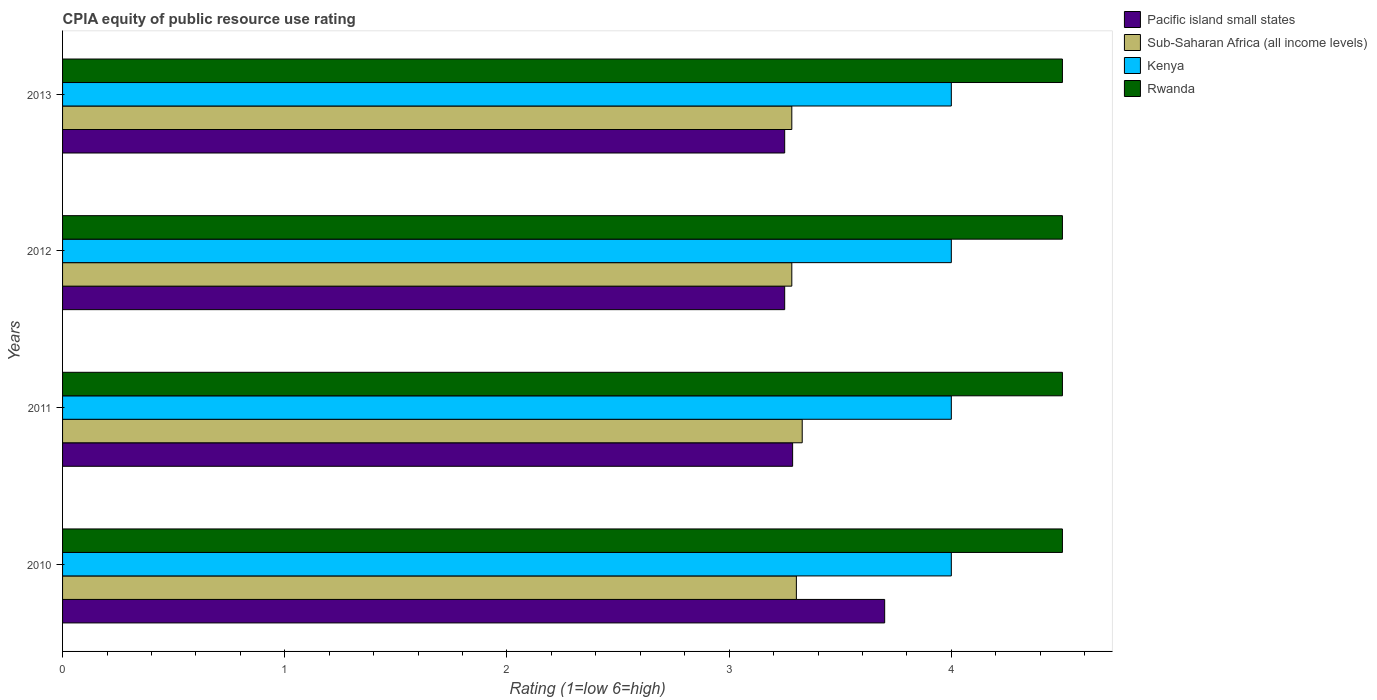How many different coloured bars are there?
Keep it short and to the point. 4. How many groups of bars are there?
Give a very brief answer. 4. Are the number of bars per tick equal to the number of legend labels?
Ensure brevity in your answer.  Yes. Are the number of bars on each tick of the Y-axis equal?
Your answer should be compact. Yes. What is the CPIA rating in Kenya in 2010?
Provide a short and direct response. 4. Across all years, what is the maximum CPIA rating in Kenya?
Provide a short and direct response. 4. Across all years, what is the minimum CPIA rating in Rwanda?
Ensure brevity in your answer.  4.5. In which year was the CPIA rating in Rwanda minimum?
Make the answer very short. 2010. What is the total CPIA rating in Kenya in the graph?
Give a very brief answer. 16. What is the difference between the CPIA rating in Sub-Saharan Africa (all income levels) in 2011 and that in 2012?
Your response must be concise. 0.05. What is the difference between the CPIA rating in Pacific island small states in 2011 and the CPIA rating in Kenya in 2013?
Your answer should be compact. -0.71. What is the average CPIA rating in Kenya per year?
Provide a short and direct response. 4. In the year 2010, what is the difference between the CPIA rating in Sub-Saharan Africa (all income levels) and CPIA rating in Rwanda?
Offer a terse response. -1.2. What is the ratio of the CPIA rating in Pacific island small states in 2011 to that in 2012?
Your answer should be compact. 1.01. What is the difference between the highest and the second highest CPIA rating in Pacific island small states?
Ensure brevity in your answer.  0.41. What is the difference between the highest and the lowest CPIA rating in Rwanda?
Your answer should be very brief. 0. In how many years, is the CPIA rating in Pacific island small states greater than the average CPIA rating in Pacific island small states taken over all years?
Your answer should be very brief. 1. Is the sum of the CPIA rating in Rwanda in 2012 and 2013 greater than the maximum CPIA rating in Pacific island small states across all years?
Keep it short and to the point. Yes. Is it the case that in every year, the sum of the CPIA rating in Kenya and CPIA rating in Sub-Saharan Africa (all income levels) is greater than the sum of CPIA rating in Rwanda and CPIA rating in Pacific island small states?
Offer a terse response. No. What does the 4th bar from the top in 2013 represents?
Your answer should be compact. Pacific island small states. What does the 2nd bar from the bottom in 2010 represents?
Offer a terse response. Sub-Saharan Africa (all income levels). Is it the case that in every year, the sum of the CPIA rating in Kenya and CPIA rating in Rwanda is greater than the CPIA rating in Pacific island small states?
Make the answer very short. Yes. Are all the bars in the graph horizontal?
Give a very brief answer. Yes. What is the difference between two consecutive major ticks on the X-axis?
Provide a short and direct response. 1. Does the graph contain grids?
Make the answer very short. No. What is the title of the graph?
Provide a short and direct response. CPIA equity of public resource use rating. Does "Pacific island small states" appear as one of the legend labels in the graph?
Offer a very short reply. Yes. What is the label or title of the Y-axis?
Give a very brief answer. Years. What is the Rating (1=low 6=high) of Sub-Saharan Africa (all income levels) in 2010?
Your answer should be very brief. 3.3. What is the Rating (1=low 6=high) of Pacific island small states in 2011?
Give a very brief answer. 3.29. What is the Rating (1=low 6=high) of Sub-Saharan Africa (all income levels) in 2011?
Give a very brief answer. 3.33. What is the Rating (1=low 6=high) in Sub-Saharan Africa (all income levels) in 2012?
Make the answer very short. 3.28. What is the Rating (1=low 6=high) of Rwanda in 2012?
Keep it short and to the point. 4.5. What is the Rating (1=low 6=high) of Pacific island small states in 2013?
Provide a succinct answer. 3.25. What is the Rating (1=low 6=high) in Sub-Saharan Africa (all income levels) in 2013?
Your answer should be very brief. 3.28. What is the Rating (1=low 6=high) in Kenya in 2013?
Offer a terse response. 4. Across all years, what is the maximum Rating (1=low 6=high) of Pacific island small states?
Provide a succinct answer. 3.7. Across all years, what is the maximum Rating (1=low 6=high) in Sub-Saharan Africa (all income levels)?
Make the answer very short. 3.33. Across all years, what is the minimum Rating (1=low 6=high) of Sub-Saharan Africa (all income levels)?
Ensure brevity in your answer.  3.28. Across all years, what is the minimum Rating (1=low 6=high) in Kenya?
Your answer should be compact. 4. Across all years, what is the minimum Rating (1=low 6=high) of Rwanda?
Give a very brief answer. 4.5. What is the total Rating (1=low 6=high) of Pacific island small states in the graph?
Make the answer very short. 13.49. What is the total Rating (1=low 6=high) in Sub-Saharan Africa (all income levels) in the graph?
Your answer should be very brief. 13.2. What is the total Rating (1=low 6=high) of Kenya in the graph?
Your answer should be very brief. 16. What is the difference between the Rating (1=low 6=high) in Pacific island small states in 2010 and that in 2011?
Offer a terse response. 0.41. What is the difference between the Rating (1=low 6=high) in Sub-Saharan Africa (all income levels) in 2010 and that in 2011?
Provide a succinct answer. -0.03. What is the difference between the Rating (1=low 6=high) in Kenya in 2010 and that in 2011?
Your answer should be compact. 0. What is the difference between the Rating (1=low 6=high) of Pacific island small states in 2010 and that in 2012?
Keep it short and to the point. 0.45. What is the difference between the Rating (1=low 6=high) of Sub-Saharan Africa (all income levels) in 2010 and that in 2012?
Provide a succinct answer. 0.02. What is the difference between the Rating (1=low 6=high) in Rwanda in 2010 and that in 2012?
Your answer should be compact. 0. What is the difference between the Rating (1=low 6=high) in Pacific island small states in 2010 and that in 2013?
Give a very brief answer. 0.45. What is the difference between the Rating (1=low 6=high) of Sub-Saharan Africa (all income levels) in 2010 and that in 2013?
Make the answer very short. 0.02. What is the difference between the Rating (1=low 6=high) of Kenya in 2010 and that in 2013?
Offer a very short reply. 0. What is the difference between the Rating (1=low 6=high) of Pacific island small states in 2011 and that in 2012?
Keep it short and to the point. 0.04. What is the difference between the Rating (1=low 6=high) in Sub-Saharan Africa (all income levels) in 2011 and that in 2012?
Offer a very short reply. 0.05. What is the difference between the Rating (1=low 6=high) in Rwanda in 2011 and that in 2012?
Ensure brevity in your answer.  0. What is the difference between the Rating (1=low 6=high) of Pacific island small states in 2011 and that in 2013?
Provide a short and direct response. 0.04. What is the difference between the Rating (1=low 6=high) of Sub-Saharan Africa (all income levels) in 2011 and that in 2013?
Keep it short and to the point. 0.05. What is the difference between the Rating (1=low 6=high) in Kenya in 2011 and that in 2013?
Keep it short and to the point. 0. What is the difference between the Rating (1=low 6=high) of Rwanda in 2011 and that in 2013?
Your response must be concise. 0. What is the difference between the Rating (1=low 6=high) in Pacific island small states in 2010 and the Rating (1=low 6=high) in Sub-Saharan Africa (all income levels) in 2011?
Provide a succinct answer. 0.37. What is the difference between the Rating (1=low 6=high) of Sub-Saharan Africa (all income levels) in 2010 and the Rating (1=low 6=high) of Kenya in 2011?
Your answer should be very brief. -0.7. What is the difference between the Rating (1=low 6=high) in Sub-Saharan Africa (all income levels) in 2010 and the Rating (1=low 6=high) in Rwanda in 2011?
Keep it short and to the point. -1.2. What is the difference between the Rating (1=low 6=high) in Kenya in 2010 and the Rating (1=low 6=high) in Rwanda in 2011?
Your answer should be compact. -0.5. What is the difference between the Rating (1=low 6=high) in Pacific island small states in 2010 and the Rating (1=low 6=high) in Sub-Saharan Africa (all income levels) in 2012?
Provide a succinct answer. 0.42. What is the difference between the Rating (1=low 6=high) of Pacific island small states in 2010 and the Rating (1=low 6=high) of Kenya in 2012?
Your answer should be compact. -0.3. What is the difference between the Rating (1=low 6=high) in Sub-Saharan Africa (all income levels) in 2010 and the Rating (1=low 6=high) in Kenya in 2012?
Keep it short and to the point. -0.7. What is the difference between the Rating (1=low 6=high) of Sub-Saharan Africa (all income levels) in 2010 and the Rating (1=low 6=high) of Rwanda in 2012?
Keep it short and to the point. -1.2. What is the difference between the Rating (1=low 6=high) of Pacific island small states in 2010 and the Rating (1=low 6=high) of Sub-Saharan Africa (all income levels) in 2013?
Offer a terse response. 0.42. What is the difference between the Rating (1=low 6=high) of Pacific island small states in 2010 and the Rating (1=low 6=high) of Kenya in 2013?
Your answer should be very brief. -0.3. What is the difference between the Rating (1=low 6=high) of Sub-Saharan Africa (all income levels) in 2010 and the Rating (1=low 6=high) of Kenya in 2013?
Keep it short and to the point. -0.7. What is the difference between the Rating (1=low 6=high) in Sub-Saharan Africa (all income levels) in 2010 and the Rating (1=low 6=high) in Rwanda in 2013?
Provide a succinct answer. -1.2. What is the difference between the Rating (1=low 6=high) in Pacific island small states in 2011 and the Rating (1=low 6=high) in Sub-Saharan Africa (all income levels) in 2012?
Your answer should be very brief. 0. What is the difference between the Rating (1=low 6=high) in Pacific island small states in 2011 and the Rating (1=low 6=high) in Kenya in 2012?
Your response must be concise. -0.71. What is the difference between the Rating (1=low 6=high) in Pacific island small states in 2011 and the Rating (1=low 6=high) in Rwanda in 2012?
Provide a succinct answer. -1.21. What is the difference between the Rating (1=low 6=high) of Sub-Saharan Africa (all income levels) in 2011 and the Rating (1=low 6=high) of Kenya in 2012?
Offer a very short reply. -0.67. What is the difference between the Rating (1=low 6=high) in Sub-Saharan Africa (all income levels) in 2011 and the Rating (1=low 6=high) in Rwanda in 2012?
Your answer should be very brief. -1.17. What is the difference between the Rating (1=low 6=high) in Pacific island small states in 2011 and the Rating (1=low 6=high) in Sub-Saharan Africa (all income levels) in 2013?
Ensure brevity in your answer.  0. What is the difference between the Rating (1=low 6=high) of Pacific island small states in 2011 and the Rating (1=low 6=high) of Kenya in 2013?
Your answer should be very brief. -0.71. What is the difference between the Rating (1=low 6=high) in Pacific island small states in 2011 and the Rating (1=low 6=high) in Rwanda in 2013?
Provide a succinct answer. -1.21. What is the difference between the Rating (1=low 6=high) of Sub-Saharan Africa (all income levels) in 2011 and the Rating (1=low 6=high) of Kenya in 2013?
Keep it short and to the point. -0.67. What is the difference between the Rating (1=low 6=high) in Sub-Saharan Africa (all income levels) in 2011 and the Rating (1=low 6=high) in Rwanda in 2013?
Ensure brevity in your answer.  -1.17. What is the difference between the Rating (1=low 6=high) in Pacific island small states in 2012 and the Rating (1=low 6=high) in Sub-Saharan Africa (all income levels) in 2013?
Provide a short and direct response. -0.03. What is the difference between the Rating (1=low 6=high) of Pacific island small states in 2012 and the Rating (1=low 6=high) of Kenya in 2013?
Provide a short and direct response. -0.75. What is the difference between the Rating (1=low 6=high) in Pacific island small states in 2012 and the Rating (1=low 6=high) in Rwanda in 2013?
Provide a succinct answer. -1.25. What is the difference between the Rating (1=low 6=high) of Sub-Saharan Africa (all income levels) in 2012 and the Rating (1=low 6=high) of Kenya in 2013?
Provide a succinct answer. -0.72. What is the difference between the Rating (1=low 6=high) of Sub-Saharan Africa (all income levels) in 2012 and the Rating (1=low 6=high) of Rwanda in 2013?
Keep it short and to the point. -1.22. What is the average Rating (1=low 6=high) of Pacific island small states per year?
Offer a terse response. 3.37. What is the average Rating (1=low 6=high) of Sub-Saharan Africa (all income levels) per year?
Ensure brevity in your answer.  3.3. In the year 2010, what is the difference between the Rating (1=low 6=high) of Pacific island small states and Rating (1=low 6=high) of Sub-Saharan Africa (all income levels)?
Your answer should be compact. 0.4. In the year 2010, what is the difference between the Rating (1=low 6=high) in Pacific island small states and Rating (1=low 6=high) in Rwanda?
Offer a very short reply. -0.8. In the year 2010, what is the difference between the Rating (1=low 6=high) in Sub-Saharan Africa (all income levels) and Rating (1=low 6=high) in Kenya?
Ensure brevity in your answer.  -0.7. In the year 2010, what is the difference between the Rating (1=low 6=high) of Sub-Saharan Africa (all income levels) and Rating (1=low 6=high) of Rwanda?
Provide a short and direct response. -1.2. In the year 2011, what is the difference between the Rating (1=low 6=high) in Pacific island small states and Rating (1=low 6=high) in Sub-Saharan Africa (all income levels)?
Ensure brevity in your answer.  -0.04. In the year 2011, what is the difference between the Rating (1=low 6=high) in Pacific island small states and Rating (1=low 6=high) in Kenya?
Provide a succinct answer. -0.71. In the year 2011, what is the difference between the Rating (1=low 6=high) of Pacific island small states and Rating (1=low 6=high) of Rwanda?
Provide a short and direct response. -1.21. In the year 2011, what is the difference between the Rating (1=low 6=high) of Sub-Saharan Africa (all income levels) and Rating (1=low 6=high) of Kenya?
Provide a short and direct response. -0.67. In the year 2011, what is the difference between the Rating (1=low 6=high) in Sub-Saharan Africa (all income levels) and Rating (1=low 6=high) in Rwanda?
Your answer should be very brief. -1.17. In the year 2012, what is the difference between the Rating (1=low 6=high) of Pacific island small states and Rating (1=low 6=high) of Sub-Saharan Africa (all income levels)?
Provide a succinct answer. -0.03. In the year 2012, what is the difference between the Rating (1=low 6=high) in Pacific island small states and Rating (1=low 6=high) in Kenya?
Make the answer very short. -0.75. In the year 2012, what is the difference between the Rating (1=low 6=high) of Pacific island small states and Rating (1=low 6=high) of Rwanda?
Your answer should be compact. -1.25. In the year 2012, what is the difference between the Rating (1=low 6=high) of Sub-Saharan Africa (all income levels) and Rating (1=low 6=high) of Kenya?
Offer a very short reply. -0.72. In the year 2012, what is the difference between the Rating (1=low 6=high) in Sub-Saharan Africa (all income levels) and Rating (1=low 6=high) in Rwanda?
Your response must be concise. -1.22. In the year 2013, what is the difference between the Rating (1=low 6=high) in Pacific island small states and Rating (1=low 6=high) in Sub-Saharan Africa (all income levels)?
Offer a very short reply. -0.03. In the year 2013, what is the difference between the Rating (1=low 6=high) in Pacific island small states and Rating (1=low 6=high) in Kenya?
Keep it short and to the point. -0.75. In the year 2013, what is the difference between the Rating (1=low 6=high) in Pacific island small states and Rating (1=low 6=high) in Rwanda?
Give a very brief answer. -1.25. In the year 2013, what is the difference between the Rating (1=low 6=high) in Sub-Saharan Africa (all income levels) and Rating (1=low 6=high) in Kenya?
Your answer should be compact. -0.72. In the year 2013, what is the difference between the Rating (1=low 6=high) of Sub-Saharan Africa (all income levels) and Rating (1=low 6=high) of Rwanda?
Make the answer very short. -1.22. In the year 2013, what is the difference between the Rating (1=low 6=high) of Kenya and Rating (1=low 6=high) of Rwanda?
Offer a very short reply. -0.5. What is the ratio of the Rating (1=low 6=high) of Pacific island small states in 2010 to that in 2011?
Your response must be concise. 1.13. What is the ratio of the Rating (1=low 6=high) in Kenya in 2010 to that in 2011?
Offer a very short reply. 1. What is the ratio of the Rating (1=low 6=high) of Pacific island small states in 2010 to that in 2012?
Offer a terse response. 1.14. What is the ratio of the Rating (1=low 6=high) of Kenya in 2010 to that in 2012?
Offer a very short reply. 1. What is the ratio of the Rating (1=low 6=high) of Rwanda in 2010 to that in 2012?
Your answer should be very brief. 1. What is the ratio of the Rating (1=low 6=high) of Pacific island small states in 2010 to that in 2013?
Give a very brief answer. 1.14. What is the ratio of the Rating (1=low 6=high) in Rwanda in 2010 to that in 2013?
Offer a very short reply. 1. What is the ratio of the Rating (1=low 6=high) of Pacific island small states in 2011 to that in 2012?
Keep it short and to the point. 1.01. What is the ratio of the Rating (1=low 6=high) of Sub-Saharan Africa (all income levels) in 2011 to that in 2012?
Ensure brevity in your answer.  1.01. What is the ratio of the Rating (1=low 6=high) of Pacific island small states in 2011 to that in 2013?
Offer a terse response. 1.01. What is the ratio of the Rating (1=low 6=high) in Sub-Saharan Africa (all income levels) in 2011 to that in 2013?
Your answer should be very brief. 1.01. What is the ratio of the Rating (1=low 6=high) in Kenya in 2011 to that in 2013?
Your answer should be compact. 1. What is the ratio of the Rating (1=low 6=high) of Rwanda in 2011 to that in 2013?
Give a very brief answer. 1. What is the ratio of the Rating (1=low 6=high) of Sub-Saharan Africa (all income levels) in 2012 to that in 2013?
Offer a terse response. 1. What is the ratio of the Rating (1=low 6=high) in Rwanda in 2012 to that in 2013?
Keep it short and to the point. 1. What is the difference between the highest and the second highest Rating (1=low 6=high) of Pacific island small states?
Provide a short and direct response. 0.41. What is the difference between the highest and the second highest Rating (1=low 6=high) in Sub-Saharan Africa (all income levels)?
Your response must be concise. 0.03. What is the difference between the highest and the second highest Rating (1=low 6=high) in Kenya?
Provide a succinct answer. 0. What is the difference between the highest and the lowest Rating (1=low 6=high) of Pacific island small states?
Your answer should be very brief. 0.45. What is the difference between the highest and the lowest Rating (1=low 6=high) in Sub-Saharan Africa (all income levels)?
Your answer should be very brief. 0.05. What is the difference between the highest and the lowest Rating (1=low 6=high) in Rwanda?
Your response must be concise. 0. 